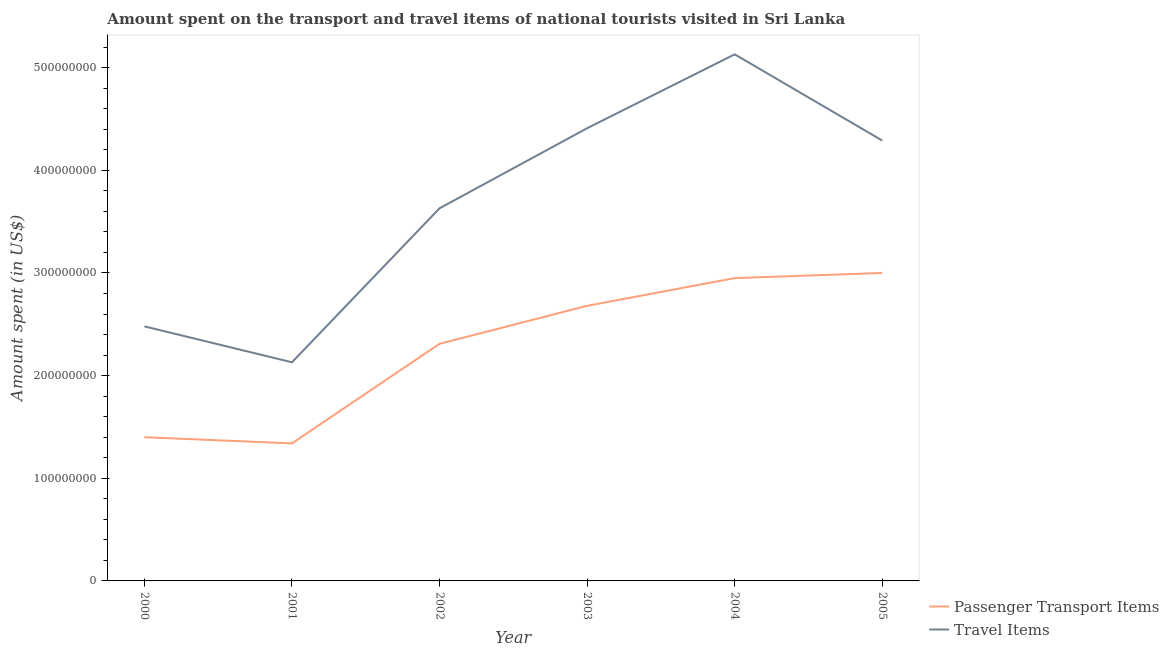How many different coloured lines are there?
Your answer should be very brief. 2. Does the line corresponding to amount spent on passenger transport items intersect with the line corresponding to amount spent in travel items?
Your response must be concise. No. What is the amount spent on passenger transport items in 2004?
Offer a very short reply. 2.95e+08. Across all years, what is the maximum amount spent in travel items?
Your response must be concise. 5.13e+08. Across all years, what is the minimum amount spent on passenger transport items?
Give a very brief answer. 1.34e+08. What is the total amount spent in travel items in the graph?
Ensure brevity in your answer.  2.21e+09. What is the difference between the amount spent in travel items in 2001 and that in 2002?
Provide a short and direct response. -1.50e+08. What is the difference between the amount spent on passenger transport items in 2002 and the amount spent in travel items in 2000?
Your response must be concise. -1.70e+07. What is the average amount spent on passenger transport items per year?
Provide a short and direct response. 2.28e+08. In the year 2003, what is the difference between the amount spent on passenger transport items and amount spent in travel items?
Keep it short and to the point. -1.73e+08. In how many years, is the amount spent on passenger transport items greater than 500000000 US$?
Offer a very short reply. 0. What is the ratio of the amount spent on passenger transport items in 2001 to that in 2004?
Keep it short and to the point. 0.45. Is the amount spent on passenger transport items in 2000 less than that in 2005?
Provide a short and direct response. Yes. What is the difference between the highest and the lowest amount spent on passenger transport items?
Offer a terse response. 1.66e+08. In how many years, is the amount spent in travel items greater than the average amount spent in travel items taken over all years?
Give a very brief answer. 3. Is the sum of the amount spent in travel items in 2001 and 2004 greater than the maximum amount spent on passenger transport items across all years?
Your answer should be compact. Yes. Does the amount spent in travel items monotonically increase over the years?
Keep it short and to the point. No. Is the amount spent in travel items strictly less than the amount spent on passenger transport items over the years?
Your answer should be very brief. No. How many years are there in the graph?
Your answer should be very brief. 6. What is the difference between two consecutive major ticks on the Y-axis?
Your answer should be very brief. 1.00e+08. Are the values on the major ticks of Y-axis written in scientific E-notation?
Your response must be concise. No. Does the graph contain grids?
Your response must be concise. No. How many legend labels are there?
Make the answer very short. 2. What is the title of the graph?
Your answer should be compact. Amount spent on the transport and travel items of national tourists visited in Sri Lanka. What is the label or title of the Y-axis?
Give a very brief answer. Amount spent (in US$). What is the Amount spent (in US$) of Passenger Transport Items in 2000?
Your response must be concise. 1.40e+08. What is the Amount spent (in US$) of Travel Items in 2000?
Your answer should be compact. 2.48e+08. What is the Amount spent (in US$) of Passenger Transport Items in 2001?
Provide a succinct answer. 1.34e+08. What is the Amount spent (in US$) in Travel Items in 2001?
Ensure brevity in your answer.  2.13e+08. What is the Amount spent (in US$) in Passenger Transport Items in 2002?
Give a very brief answer. 2.31e+08. What is the Amount spent (in US$) in Travel Items in 2002?
Your answer should be very brief. 3.63e+08. What is the Amount spent (in US$) of Passenger Transport Items in 2003?
Your answer should be compact. 2.68e+08. What is the Amount spent (in US$) in Travel Items in 2003?
Make the answer very short. 4.41e+08. What is the Amount spent (in US$) of Passenger Transport Items in 2004?
Provide a succinct answer. 2.95e+08. What is the Amount spent (in US$) of Travel Items in 2004?
Offer a very short reply. 5.13e+08. What is the Amount spent (in US$) of Passenger Transport Items in 2005?
Make the answer very short. 3.00e+08. What is the Amount spent (in US$) in Travel Items in 2005?
Keep it short and to the point. 4.29e+08. Across all years, what is the maximum Amount spent (in US$) of Passenger Transport Items?
Your response must be concise. 3.00e+08. Across all years, what is the maximum Amount spent (in US$) in Travel Items?
Make the answer very short. 5.13e+08. Across all years, what is the minimum Amount spent (in US$) of Passenger Transport Items?
Make the answer very short. 1.34e+08. Across all years, what is the minimum Amount spent (in US$) of Travel Items?
Give a very brief answer. 2.13e+08. What is the total Amount spent (in US$) of Passenger Transport Items in the graph?
Your response must be concise. 1.37e+09. What is the total Amount spent (in US$) in Travel Items in the graph?
Make the answer very short. 2.21e+09. What is the difference between the Amount spent (in US$) of Passenger Transport Items in 2000 and that in 2001?
Your answer should be compact. 6.00e+06. What is the difference between the Amount spent (in US$) in Travel Items in 2000 and that in 2001?
Provide a short and direct response. 3.50e+07. What is the difference between the Amount spent (in US$) in Passenger Transport Items in 2000 and that in 2002?
Offer a very short reply. -9.10e+07. What is the difference between the Amount spent (in US$) of Travel Items in 2000 and that in 2002?
Offer a very short reply. -1.15e+08. What is the difference between the Amount spent (in US$) in Passenger Transport Items in 2000 and that in 2003?
Give a very brief answer. -1.28e+08. What is the difference between the Amount spent (in US$) of Travel Items in 2000 and that in 2003?
Your response must be concise. -1.93e+08. What is the difference between the Amount spent (in US$) in Passenger Transport Items in 2000 and that in 2004?
Offer a very short reply. -1.55e+08. What is the difference between the Amount spent (in US$) of Travel Items in 2000 and that in 2004?
Your answer should be very brief. -2.65e+08. What is the difference between the Amount spent (in US$) of Passenger Transport Items in 2000 and that in 2005?
Keep it short and to the point. -1.60e+08. What is the difference between the Amount spent (in US$) in Travel Items in 2000 and that in 2005?
Make the answer very short. -1.81e+08. What is the difference between the Amount spent (in US$) in Passenger Transport Items in 2001 and that in 2002?
Give a very brief answer. -9.70e+07. What is the difference between the Amount spent (in US$) of Travel Items in 2001 and that in 2002?
Make the answer very short. -1.50e+08. What is the difference between the Amount spent (in US$) of Passenger Transport Items in 2001 and that in 2003?
Keep it short and to the point. -1.34e+08. What is the difference between the Amount spent (in US$) in Travel Items in 2001 and that in 2003?
Keep it short and to the point. -2.28e+08. What is the difference between the Amount spent (in US$) in Passenger Transport Items in 2001 and that in 2004?
Offer a terse response. -1.61e+08. What is the difference between the Amount spent (in US$) in Travel Items in 2001 and that in 2004?
Your answer should be very brief. -3.00e+08. What is the difference between the Amount spent (in US$) in Passenger Transport Items in 2001 and that in 2005?
Ensure brevity in your answer.  -1.66e+08. What is the difference between the Amount spent (in US$) in Travel Items in 2001 and that in 2005?
Offer a very short reply. -2.16e+08. What is the difference between the Amount spent (in US$) of Passenger Transport Items in 2002 and that in 2003?
Ensure brevity in your answer.  -3.70e+07. What is the difference between the Amount spent (in US$) of Travel Items in 2002 and that in 2003?
Ensure brevity in your answer.  -7.80e+07. What is the difference between the Amount spent (in US$) of Passenger Transport Items in 2002 and that in 2004?
Offer a terse response. -6.40e+07. What is the difference between the Amount spent (in US$) in Travel Items in 2002 and that in 2004?
Offer a terse response. -1.50e+08. What is the difference between the Amount spent (in US$) in Passenger Transport Items in 2002 and that in 2005?
Ensure brevity in your answer.  -6.90e+07. What is the difference between the Amount spent (in US$) of Travel Items in 2002 and that in 2005?
Give a very brief answer. -6.60e+07. What is the difference between the Amount spent (in US$) in Passenger Transport Items in 2003 and that in 2004?
Provide a succinct answer. -2.70e+07. What is the difference between the Amount spent (in US$) of Travel Items in 2003 and that in 2004?
Ensure brevity in your answer.  -7.20e+07. What is the difference between the Amount spent (in US$) of Passenger Transport Items in 2003 and that in 2005?
Provide a short and direct response. -3.20e+07. What is the difference between the Amount spent (in US$) in Travel Items in 2003 and that in 2005?
Your response must be concise. 1.20e+07. What is the difference between the Amount spent (in US$) in Passenger Transport Items in 2004 and that in 2005?
Your response must be concise. -5.00e+06. What is the difference between the Amount spent (in US$) of Travel Items in 2004 and that in 2005?
Your response must be concise. 8.40e+07. What is the difference between the Amount spent (in US$) in Passenger Transport Items in 2000 and the Amount spent (in US$) in Travel Items in 2001?
Keep it short and to the point. -7.30e+07. What is the difference between the Amount spent (in US$) in Passenger Transport Items in 2000 and the Amount spent (in US$) in Travel Items in 2002?
Your answer should be very brief. -2.23e+08. What is the difference between the Amount spent (in US$) of Passenger Transport Items in 2000 and the Amount spent (in US$) of Travel Items in 2003?
Make the answer very short. -3.01e+08. What is the difference between the Amount spent (in US$) in Passenger Transport Items in 2000 and the Amount spent (in US$) in Travel Items in 2004?
Keep it short and to the point. -3.73e+08. What is the difference between the Amount spent (in US$) in Passenger Transport Items in 2000 and the Amount spent (in US$) in Travel Items in 2005?
Offer a terse response. -2.89e+08. What is the difference between the Amount spent (in US$) of Passenger Transport Items in 2001 and the Amount spent (in US$) of Travel Items in 2002?
Your response must be concise. -2.29e+08. What is the difference between the Amount spent (in US$) of Passenger Transport Items in 2001 and the Amount spent (in US$) of Travel Items in 2003?
Your answer should be very brief. -3.07e+08. What is the difference between the Amount spent (in US$) of Passenger Transport Items in 2001 and the Amount spent (in US$) of Travel Items in 2004?
Your response must be concise. -3.79e+08. What is the difference between the Amount spent (in US$) in Passenger Transport Items in 2001 and the Amount spent (in US$) in Travel Items in 2005?
Your answer should be compact. -2.95e+08. What is the difference between the Amount spent (in US$) in Passenger Transport Items in 2002 and the Amount spent (in US$) in Travel Items in 2003?
Your answer should be very brief. -2.10e+08. What is the difference between the Amount spent (in US$) in Passenger Transport Items in 2002 and the Amount spent (in US$) in Travel Items in 2004?
Offer a terse response. -2.82e+08. What is the difference between the Amount spent (in US$) in Passenger Transport Items in 2002 and the Amount spent (in US$) in Travel Items in 2005?
Provide a succinct answer. -1.98e+08. What is the difference between the Amount spent (in US$) in Passenger Transport Items in 2003 and the Amount spent (in US$) in Travel Items in 2004?
Give a very brief answer. -2.45e+08. What is the difference between the Amount spent (in US$) of Passenger Transport Items in 2003 and the Amount spent (in US$) of Travel Items in 2005?
Your answer should be compact. -1.61e+08. What is the difference between the Amount spent (in US$) of Passenger Transport Items in 2004 and the Amount spent (in US$) of Travel Items in 2005?
Your response must be concise. -1.34e+08. What is the average Amount spent (in US$) of Passenger Transport Items per year?
Provide a succinct answer. 2.28e+08. What is the average Amount spent (in US$) of Travel Items per year?
Keep it short and to the point. 3.68e+08. In the year 2000, what is the difference between the Amount spent (in US$) of Passenger Transport Items and Amount spent (in US$) of Travel Items?
Your response must be concise. -1.08e+08. In the year 2001, what is the difference between the Amount spent (in US$) in Passenger Transport Items and Amount spent (in US$) in Travel Items?
Your response must be concise. -7.90e+07. In the year 2002, what is the difference between the Amount spent (in US$) in Passenger Transport Items and Amount spent (in US$) in Travel Items?
Ensure brevity in your answer.  -1.32e+08. In the year 2003, what is the difference between the Amount spent (in US$) in Passenger Transport Items and Amount spent (in US$) in Travel Items?
Provide a short and direct response. -1.73e+08. In the year 2004, what is the difference between the Amount spent (in US$) in Passenger Transport Items and Amount spent (in US$) in Travel Items?
Provide a succinct answer. -2.18e+08. In the year 2005, what is the difference between the Amount spent (in US$) of Passenger Transport Items and Amount spent (in US$) of Travel Items?
Your answer should be compact. -1.29e+08. What is the ratio of the Amount spent (in US$) in Passenger Transport Items in 2000 to that in 2001?
Offer a very short reply. 1.04. What is the ratio of the Amount spent (in US$) in Travel Items in 2000 to that in 2001?
Offer a terse response. 1.16. What is the ratio of the Amount spent (in US$) in Passenger Transport Items in 2000 to that in 2002?
Provide a succinct answer. 0.61. What is the ratio of the Amount spent (in US$) of Travel Items in 2000 to that in 2002?
Offer a terse response. 0.68. What is the ratio of the Amount spent (in US$) in Passenger Transport Items in 2000 to that in 2003?
Offer a terse response. 0.52. What is the ratio of the Amount spent (in US$) in Travel Items in 2000 to that in 2003?
Provide a succinct answer. 0.56. What is the ratio of the Amount spent (in US$) in Passenger Transport Items in 2000 to that in 2004?
Provide a short and direct response. 0.47. What is the ratio of the Amount spent (in US$) in Travel Items in 2000 to that in 2004?
Offer a terse response. 0.48. What is the ratio of the Amount spent (in US$) of Passenger Transport Items in 2000 to that in 2005?
Offer a terse response. 0.47. What is the ratio of the Amount spent (in US$) of Travel Items in 2000 to that in 2005?
Your answer should be compact. 0.58. What is the ratio of the Amount spent (in US$) of Passenger Transport Items in 2001 to that in 2002?
Offer a terse response. 0.58. What is the ratio of the Amount spent (in US$) in Travel Items in 2001 to that in 2002?
Your answer should be very brief. 0.59. What is the ratio of the Amount spent (in US$) of Passenger Transport Items in 2001 to that in 2003?
Your answer should be compact. 0.5. What is the ratio of the Amount spent (in US$) of Travel Items in 2001 to that in 2003?
Offer a very short reply. 0.48. What is the ratio of the Amount spent (in US$) in Passenger Transport Items in 2001 to that in 2004?
Give a very brief answer. 0.45. What is the ratio of the Amount spent (in US$) of Travel Items in 2001 to that in 2004?
Ensure brevity in your answer.  0.42. What is the ratio of the Amount spent (in US$) of Passenger Transport Items in 2001 to that in 2005?
Make the answer very short. 0.45. What is the ratio of the Amount spent (in US$) of Travel Items in 2001 to that in 2005?
Your answer should be compact. 0.5. What is the ratio of the Amount spent (in US$) in Passenger Transport Items in 2002 to that in 2003?
Make the answer very short. 0.86. What is the ratio of the Amount spent (in US$) of Travel Items in 2002 to that in 2003?
Your response must be concise. 0.82. What is the ratio of the Amount spent (in US$) in Passenger Transport Items in 2002 to that in 2004?
Give a very brief answer. 0.78. What is the ratio of the Amount spent (in US$) of Travel Items in 2002 to that in 2004?
Your response must be concise. 0.71. What is the ratio of the Amount spent (in US$) of Passenger Transport Items in 2002 to that in 2005?
Provide a short and direct response. 0.77. What is the ratio of the Amount spent (in US$) in Travel Items in 2002 to that in 2005?
Your answer should be compact. 0.85. What is the ratio of the Amount spent (in US$) in Passenger Transport Items in 2003 to that in 2004?
Offer a very short reply. 0.91. What is the ratio of the Amount spent (in US$) in Travel Items in 2003 to that in 2004?
Give a very brief answer. 0.86. What is the ratio of the Amount spent (in US$) in Passenger Transport Items in 2003 to that in 2005?
Offer a very short reply. 0.89. What is the ratio of the Amount spent (in US$) in Travel Items in 2003 to that in 2005?
Your response must be concise. 1.03. What is the ratio of the Amount spent (in US$) in Passenger Transport Items in 2004 to that in 2005?
Ensure brevity in your answer.  0.98. What is the ratio of the Amount spent (in US$) in Travel Items in 2004 to that in 2005?
Your response must be concise. 1.2. What is the difference between the highest and the second highest Amount spent (in US$) of Passenger Transport Items?
Make the answer very short. 5.00e+06. What is the difference between the highest and the second highest Amount spent (in US$) in Travel Items?
Make the answer very short. 7.20e+07. What is the difference between the highest and the lowest Amount spent (in US$) in Passenger Transport Items?
Provide a short and direct response. 1.66e+08. What is the difference between the highest and the lowest Amount spent (in US$) in Travel Items?
Ensure brevity in your answer.  3.00e+08. 